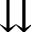<formula> <loc_0><loc_0><loc_500><loc_500>\downdownarrows</formula> 